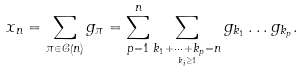Convert formula to latex. <formula><loc_0><loc_0><loc_500><loc_500>x _ { n } = \sum _ { \pi \in \mathcal { C } \left ( n \right ) } g _ { \pi } = \sum _ { p = 1 } ^ { n } \sum _ { \underset { k _ { i } \geq 1 } { k _ { 1 } + \dots + k _ { p } = n } } g _ { k _ { 1 } } \dots g _ { k _ { p } } .</formula> 